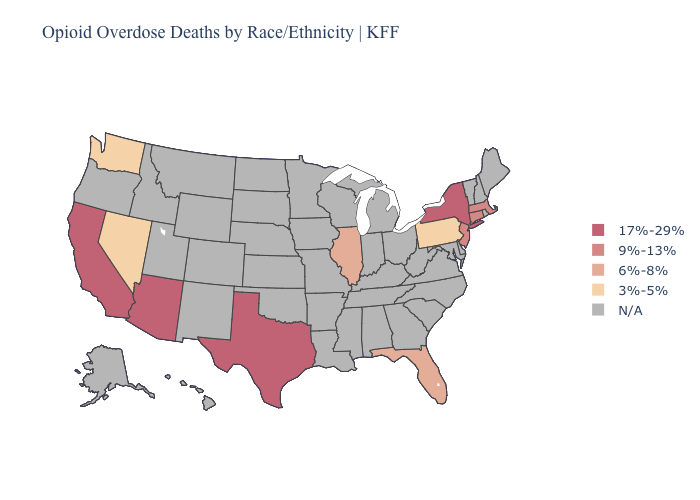Is the legend a continuous bar?
Keep it brief. No. What is the highest value in the USA?
Short answer required. 17%-29%. What is the value of Iowa?
Give a very brief answer. N/A. Does New York have the highest value in the Northeast?
Keep it brief. Yes. Name the states that have a value in the range 9%-13%?
Quick response, please. Connecticut, Massachusetts, New Jersey. Does the first symbol in the legend represent the smallest category?
Write a very short answer. No. Name the states that have a value in the range N/A?
Be succinct. Alabama, Alaska, Arkansas, Colorado, Delaware, Georgia, Hawaii, Idaho, Indiana, Iowa, Kansas, Kentucky, Louisiana, Maine, Maryland, Michigan, Minnesota, Mississippi, Missouri, Montana, Nebraska, New Hampshire, New Mexico, North Carolina, North Dakota, Ohio, Oklahoma, Oregon, Rhode Island, South Carolina, South Dakota, Tennessee, Utah, Vermont, Virginia, West Virginia, Wisconsin, Wyoming. Name the states that have a value in the range N/A?
Answer briefly. Alabama, Alaska, Arkansas, Colorado, Delaware, Georgia, Hawaii, Idaho, Indiana, Iowa, Kansas, Kentucky, Louisiana, Maine, Maryland, Michigan, Minnesota, Mississippi, Missouri, Montana, Nebraska, New Hampshire, New Mexico, North Carolina, North Dakota, Ohio, Oklahoma, Oregon, Rhode Island, South Carolina, South Dakota, Tennessee, Utah, Vermont, Virginia, West Virginia, Wisconsin, Wyoming. Is the legend a continuous bar?
Give a very brief answer. No. Among the states that border Arizona , which have the lowest value?
Answer briefly. Nevada. Is the legend a continuous bar?
Be succinct. No. Among the states that border Ohio , which have the lowest value?
Be succinct. Pennsylvania. Which states have the lowest value in the MidWest?
Concise answer only. Illinois. What is the lowest value in the USA?
Keep it brief. 3%-5%. Name the states that have a value in the range 6%-8%?
Write a very short answer. Florida, Illinois. 